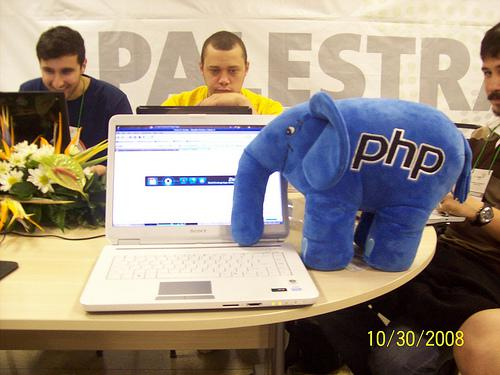Question: what animal is the stuffed animal made to resemble?
Choices:
A. Cat.
B. Elephant.
C. Dog.
D. Rooster.
Answer with the letter. Answer: B Question: what is the date in the photo?
Choices:
A. 11/15/2012.
B. 10/30/2008.
C. 6/4/2010.
D. 8/7/2000.
Answer with the letter. Answer: B Question: what is the laptop sitting on?
Choices:
A. Table.
B. Shelf.
C. Desk.
D. Floor.
Answer with the letter. Answer: A Question: what are the letters on the elephant?
Choices:
A. Prz.
B. Pmo.
C. Pjk.
D. Php.
Answer with the letter. Answer: D Question: what is in the middle of the table?
Choices:
A. Plates.
B. Flowers.
C. Statue.
D. Cat.
Answer with the letter. Answer: B 